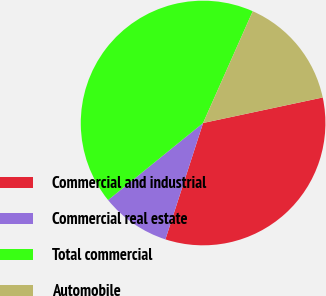Convert chart to OTSL. <chart><loc_0><loc_0><loc_500><loc_500><pie_chart><fcel>Commercial and industrial<fcel>Commercial real estate<fcel>Total commercial<fcel>Automobile<nl><fcel>33.33%<fcel>9.17%<fcel>42.5%<fcel>15.0%<nl></chart> 